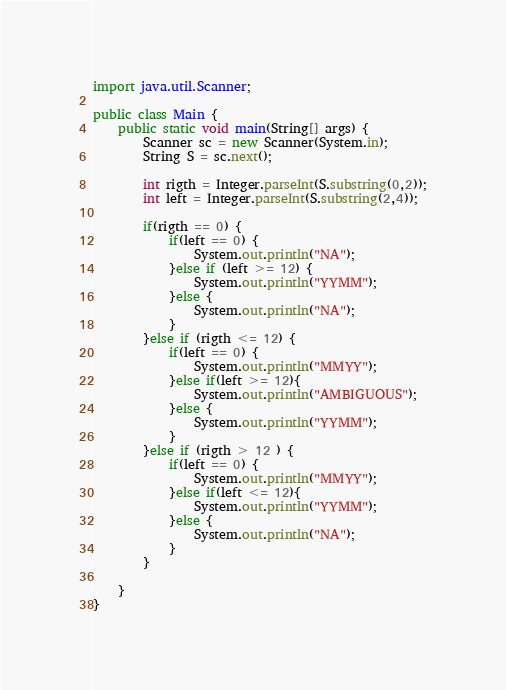Convert code to text. <code><loc_0><loc_0><loc_500><loc_500><_Java_>import java.util.Scanner;

public class Main {
	public static void main(String[] args) {
		Scanner sc = new Scanner(System.in);
		String S = sc.next();
		
		int rigth = Integer.parseInt(S.substring(0,2));
		int left = Integer.parseInt(S.substring(2,4));
		
		if(rigth == 0) {
			if(left == 0) {
				System.out.println("NA");
			}else if (left >= 12) {
				System.out.println("YYMM");
			}else {
				System.out.println("NA");
			}
		}else if (rigth <= 12) {
			if(left == 0) {
				System.out.println("MMYY");
			}else if(left >= 12){
				System.out.println("AMBIGUOUS");
			}else {
				System.out.println("YYMM");
			}
		}else if (rigth > 12 ) {
			if(left == 0) {
				System.out.println("MMYY");
			}else if(left <= 12){
				System.out.println("YYMM");
			}else {
				System.out.println("NA");
			}
		}
		
	}
}</code> 